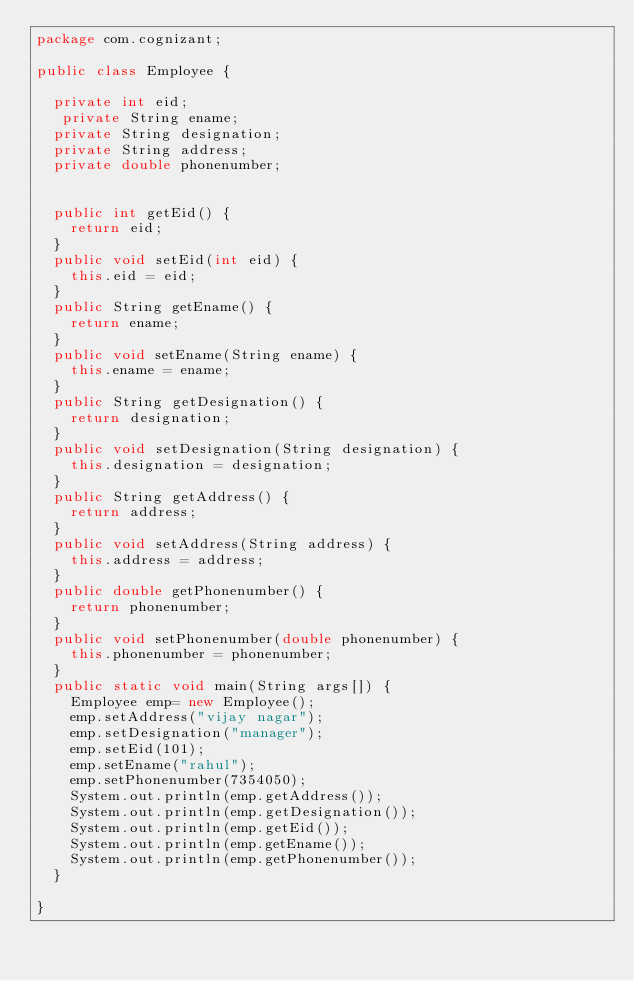Convert code to text. <code><loc_0><loc_0><loc_500><loc_500><_Java_>package com.cognizant;

public class Employee {

	private int eid;
	 private String ename;
	private String designation;
	private String address;
	private double phonenumber;
	
	
	public int getEid() {
		return eid;
	}
	public void setEid(int eid) {
		this.eid = eid;
	}
	public String getEname() {
		return ename;
	}
	public void setEname(String ename) {
		this.ename = ename;
	}
	public String getDesignation() {
		return designation;
	}
	public void setDesignation(String designation) {
		this.designation = designation;
	}
	public String getAddress() {
		return address;
	}
	public void setAddress(String address) {
		this.address = address;
	}
	public double getPhonenumber() {
		return phonenumber;
	}
	public void setPhonenumber(double phonenumber) {
		this.phonenumber = phonenumber;
	}
	public static void main(String args[]) {
		Employee emp= new Employee();
		emp.setAddress("vijay nagar");
		emp.setDesignation("manager");
		emp.setEid(101);
		emp.setEname("rahul");
		emp.setPhonenumber(7354050);
		System.out.println(emp.getAddress());
		System.out.println(emp.getDesignation());
		System.out.println(emp.getEid());
		System.out.println(emp.getEname());
		System.out.println(emp.getPhonenumber());
	}
	
}
</code> 